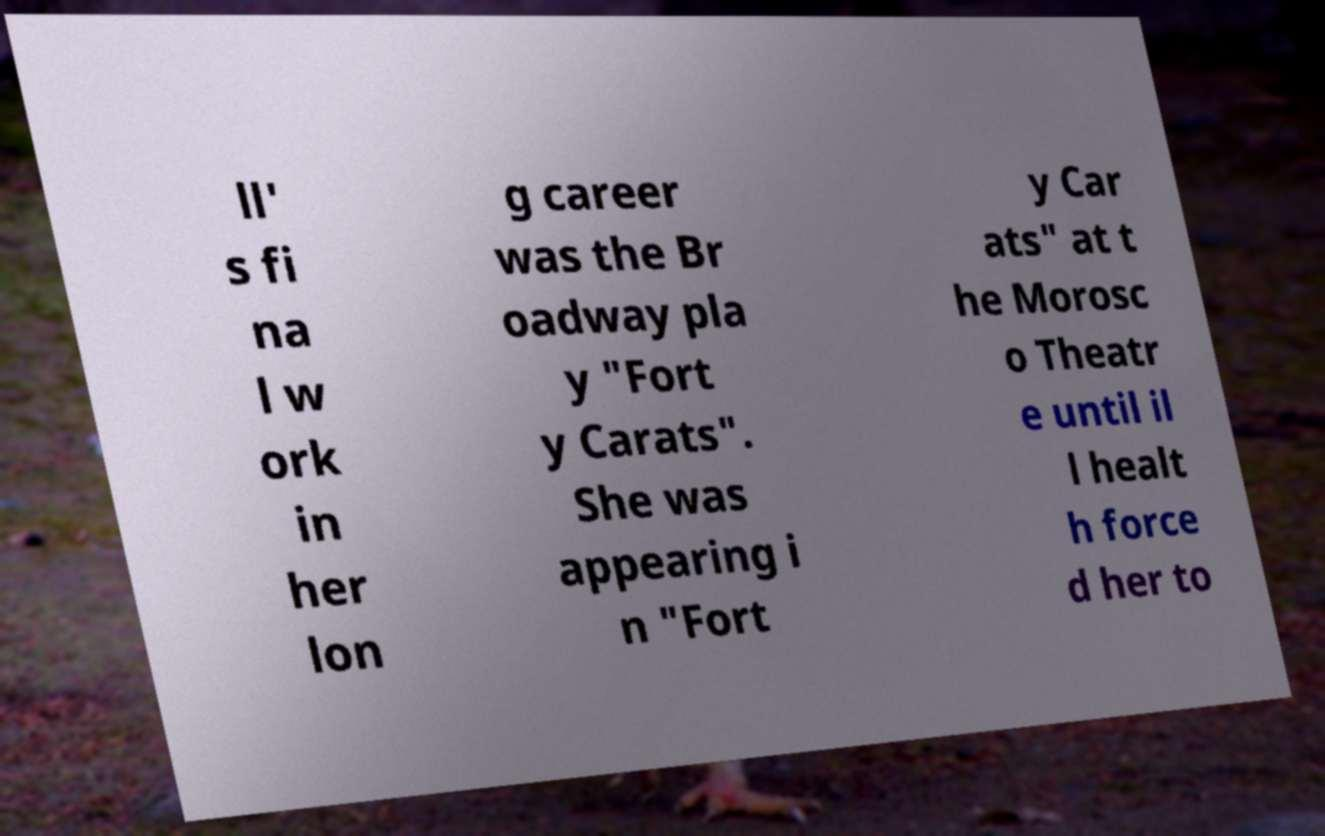Could you assist in decoding the text presented in this image and type it out clearly? ll' s fi na l w ork in her lon g career was the Br oadway pla y "Fort y Carats". She was appearing i n "Fort y Car ats" at t he Morosc o Theatr e until il l healt h force d her to 